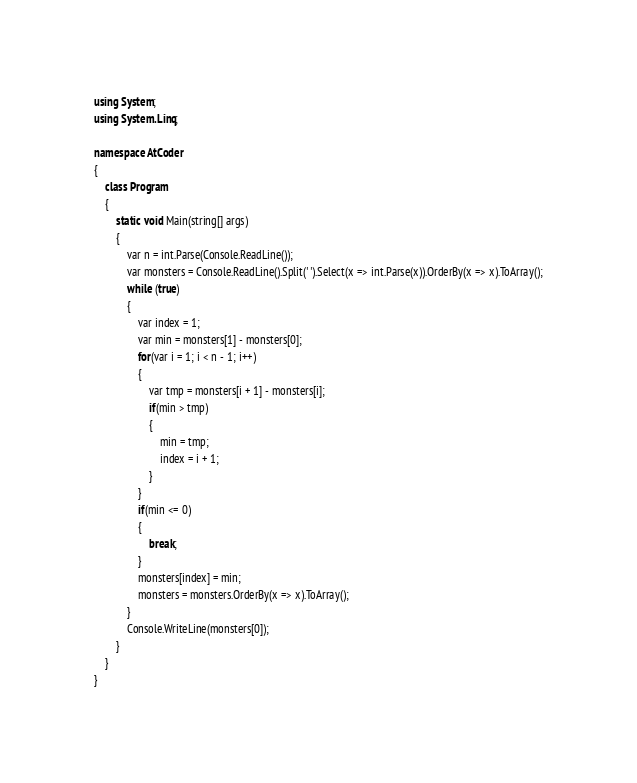Convert code to text. <code><loc_0><loc_0><loc_500><loc_500><_C#_>using System;
using System.Linq;

namespace AtCoder
{
    class Program
    {
        static void Main(string[] args)
        {
            var n = int.Parse(Console.ReadLine());
            var monsters = Console.ReadLine().Split(' ').Select(x => int.Parse(x)).OrderBy(x => x).ToArray();
            while (true)
            {
                var index = 1;
                var min = monsters[1] - monsters[0];
                for(var i = 1; i < n - 1; i++)
                {
                    var tmp = monsters[i + 1] - monsters[i];
                    if(min > tmp)
                    {
                        min = tmp;
                        index = i + 1;
                    }
                }
                if(min <= 0)
                {
                    break;
                }
                monsters[index] = min;
                monsters = monsters.OrderBy(x => x).ToArray();
            }
            Console.WriteLine(monsters[0]);
        }
    }
}
</code> 